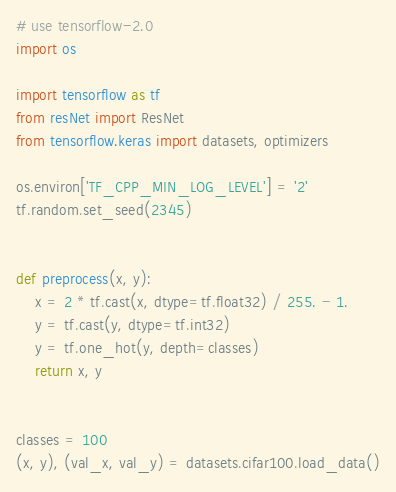<code> <loc_0><loc_0><loc_500><loc_500><_Python_># use tensorflow-2.0
import os

import tensorflow as tf
from resNet import ResNet
from tensorflow.keras import datasets, optimizers

os.environ['TF_CPP_MIN_LOG_LEVEL'] = '2'
tf.random.set_seed(2345)


def preprocess(x, y):
    x = 2 * tf.cast(x, dtype=tf.float32) / 255. - 1.
    y = tf.cast(y, dtype=tf.int32)
    y = tf.one_hot(y, depth=classes)
    return x, y


classes = 100
(x, y), (val_x, val_y) = datasets.cifar100.load_data()
</code> 